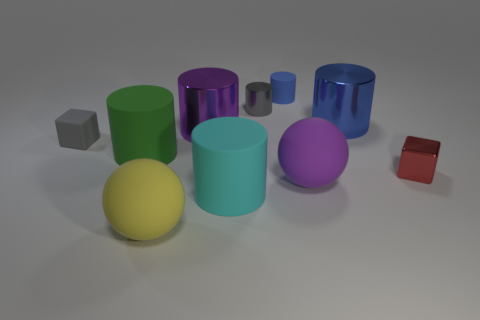The blue metal thing that is the same shape as the cyan object is what size?
Provide a short and direct response. Large. Is the big ball that is right of the small blue thing made of the same material as the gray object that is in front of the blue metallic cylinder?
Keep it short and to the point. Yes. Is the number of red cubes to the left of the small shiny cylinder less than the number of small cylinders?
Your response must be concise. Yes. What is the color of the other object that is the same shape as the red metal thing?
Provide a short and direct response. Gray. Does the gray thing that is to the right of the yellow ball have the same size as the large purple rubber ball?
Give a very brief answer. No. What size is the purple matte ball in front of the small gray object to the right of the big cyan thing?
Provide a short and direct response. Large. Is the tiny red cube made of the same material as the blue cylinder that is on the left side of the big blue metal cylinder?
Make the answer very short. No. Are there fewer small red shiny objects on the left side of the big blue thing than tiny blue rubber cylinders in front of the rubber cube?
Ensure brevity in your answer.  No. The big object that is made of the same material as the big purple cylinder is what color?
Offer a terse response. Blue. Are there any gray things behind the tiny block that is to the left of the small blue rubber cylinder?
Your response must be concise. Yes. 